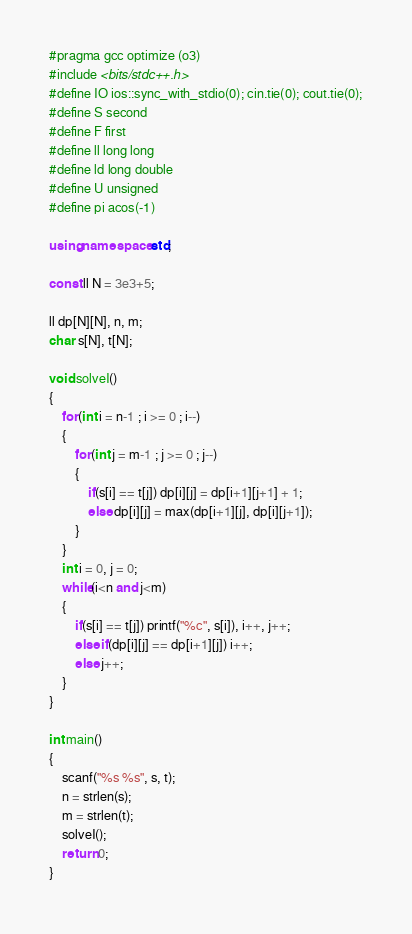<code> <loc_0><loc_0><loc_500><loc_500><_C++_>#pragma gcc optimize (o3)
#include <bits/stdc++.h>
#define IO ios::sync_with_stdio(0); cin.tie(0); cout.tie(0);
#define S second
#define F first
#define ll long long
#define ld long double
#define U unsigned
#define pi acos(-1)

using namespace std;

const ll N = 3e3+5;

ll dp[N][N], n, m;
char s[N], t[N];

void solveI()
{
    for(int i = n-1 ; i >= 0 ; i--)
    {
        for(int j = m-1 ; j >= 0 ; j--)
        {
            if(s[i] == t[j]) dp[i][j] = dp[i+1][j+1] + 1;
            else dp[i][j] = max(dp[i+1][j], dp[i][j+1]);
        }
    }
    int i = 0, j = 0;
    while(i<n and j<m)
    {
        if(s[i] == t[j]) printf("%c", s[i]), i++, j++;
        else if(dp[i][j] == dp[i+1][j]) i++;
        else j++;
    }
}

int main()
{
    scanf("%s %s", s, t);
    n = strlen(s);
    m = strlen(t);
    solveI();
    return 0;
}
</code> 